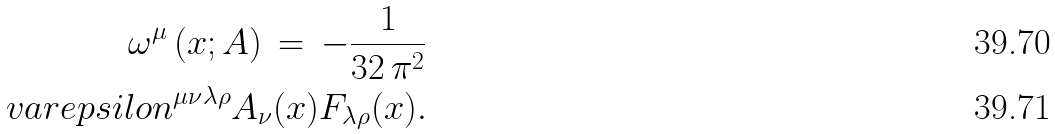Convert formula to latex. <formula><loc_0><loc_0><loc_500><loc_500>\omega ^ { \mu } \left ( x ; A \right ) \, = \, - \frac { 1 } { 3 2 \, \pi ^ { 2 } } \\ v a r e p s i l o n ^ { \mu \nu \lambda \rho } A _ { \nu } ( x ) F _ { \lambda \rho } ( x ) .</formula> 